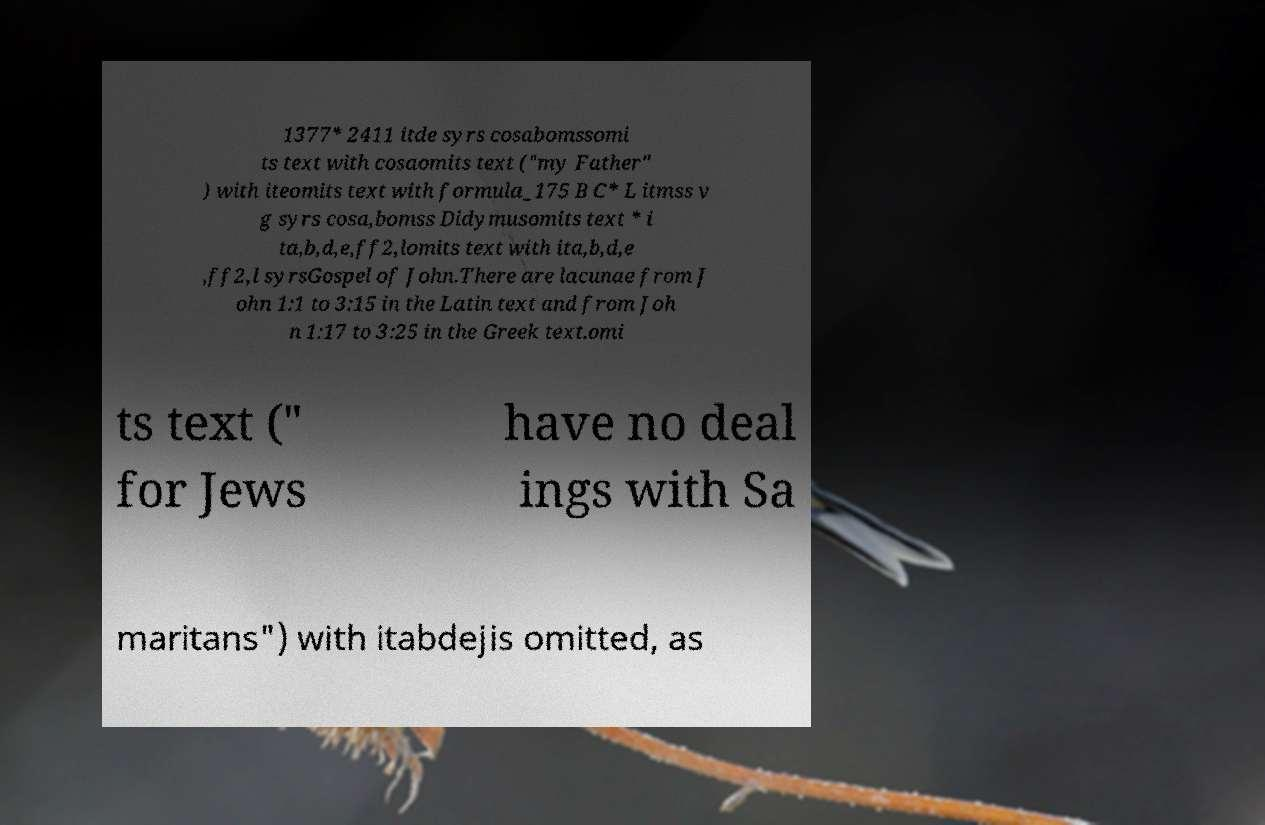What messages or text are displayed in this image? I need them in a readable, typed format. 1377* 2411 itde syrs cosabomssomi ts text with cosaomits text ("my Father" ) with iteomits text with formula_175 B C* L itmss v g syrs cosa,bomss Didymusomits text * i ta,b,d,e,ff2,lomits text with ita,b,d,e ,ff2,l syrsGospel of John.There are lacunae from J ohn 1:1 to 3:15 in the Latin text and from Joh n 1:17 to 3:25 in the Greek text.omi ts text (" for Jews have no deal ings with Sa maritans") with itabdejis omitted, as 